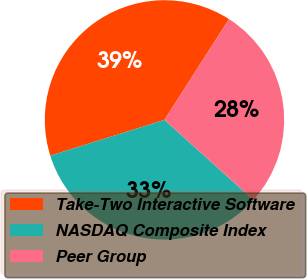Convert chart. <chart><loc_0><loc_0><loc_500><loc_500><pie_chart><fcel>Take-Two Interactive Software<fcel>NASDAQ Composite Index<fcel>Peer Group<nl><fcel>38.9%<fcel>33.49%<fcel>27.61%<nl></chart> 